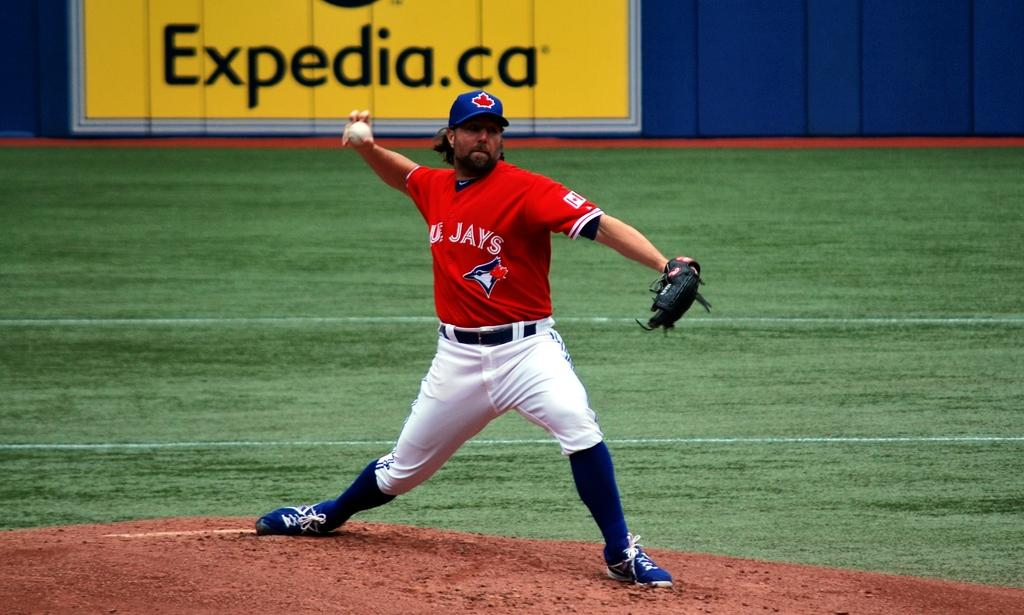<image>
Present a compact description of the photo's key features. Expedia is one of the sponsors of the game 